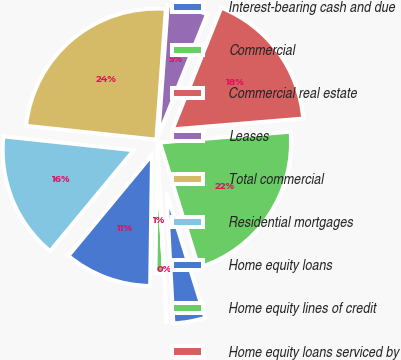<chart> <loc_0><loc_0><loc_500><loc_500><pie_chart><fcel>Interest-bearing cash and due<fcel>Commercial<fcel>Commercial real estate<fcel>Leases<fcel>Total commercial<fcel>Residential mortgages<fcel>Home equity loans<fcel>Home equity lines of credit<fcel>Home equity loans serviced by<nl><fcel>3.95%<fcel>21.53%<fcel>17.62%<fcel>4.92%<fcel>24.46%<fcel>15.67%<fcel>10.79%<fcel>1.02%<fcel>0.04%<nl></chart> 